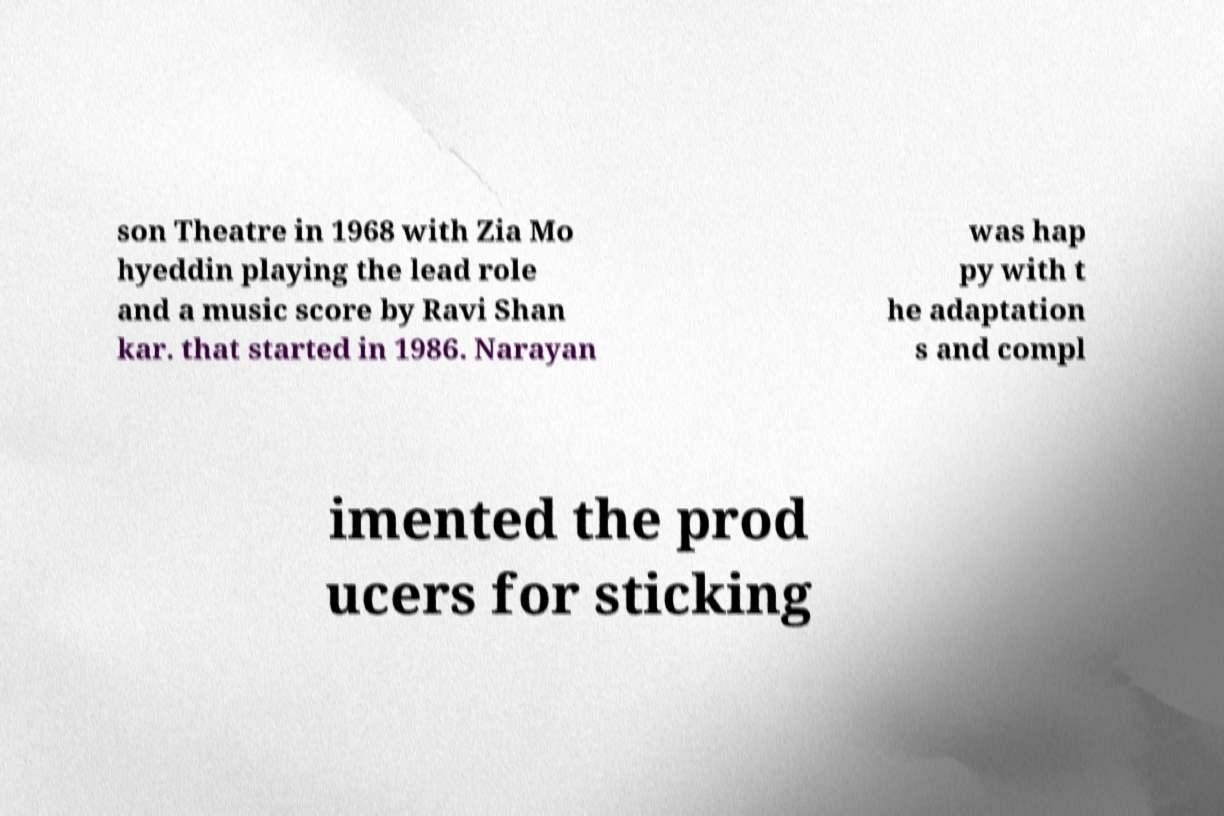Could you assist in decoding the text presented in this image and type it out clearly? son Theatre in 1968 with Zia Mo hyeddin playing the lead role and a music score by Ravi Shan kar. that started in 1986. Narayan was hap py with t he adaptation s and compl imented the prod ucers for sticking 